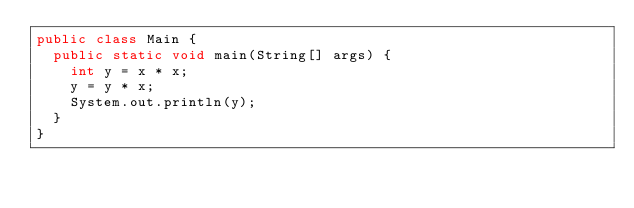<code> <loc_0><loc_0><loc_500><loc_500><_Java_>public class Main {
  public static void main(String[] args) {
    int y = x * x;
    y = y * x;
    System.out.println(y);
  }
}
 </code> 